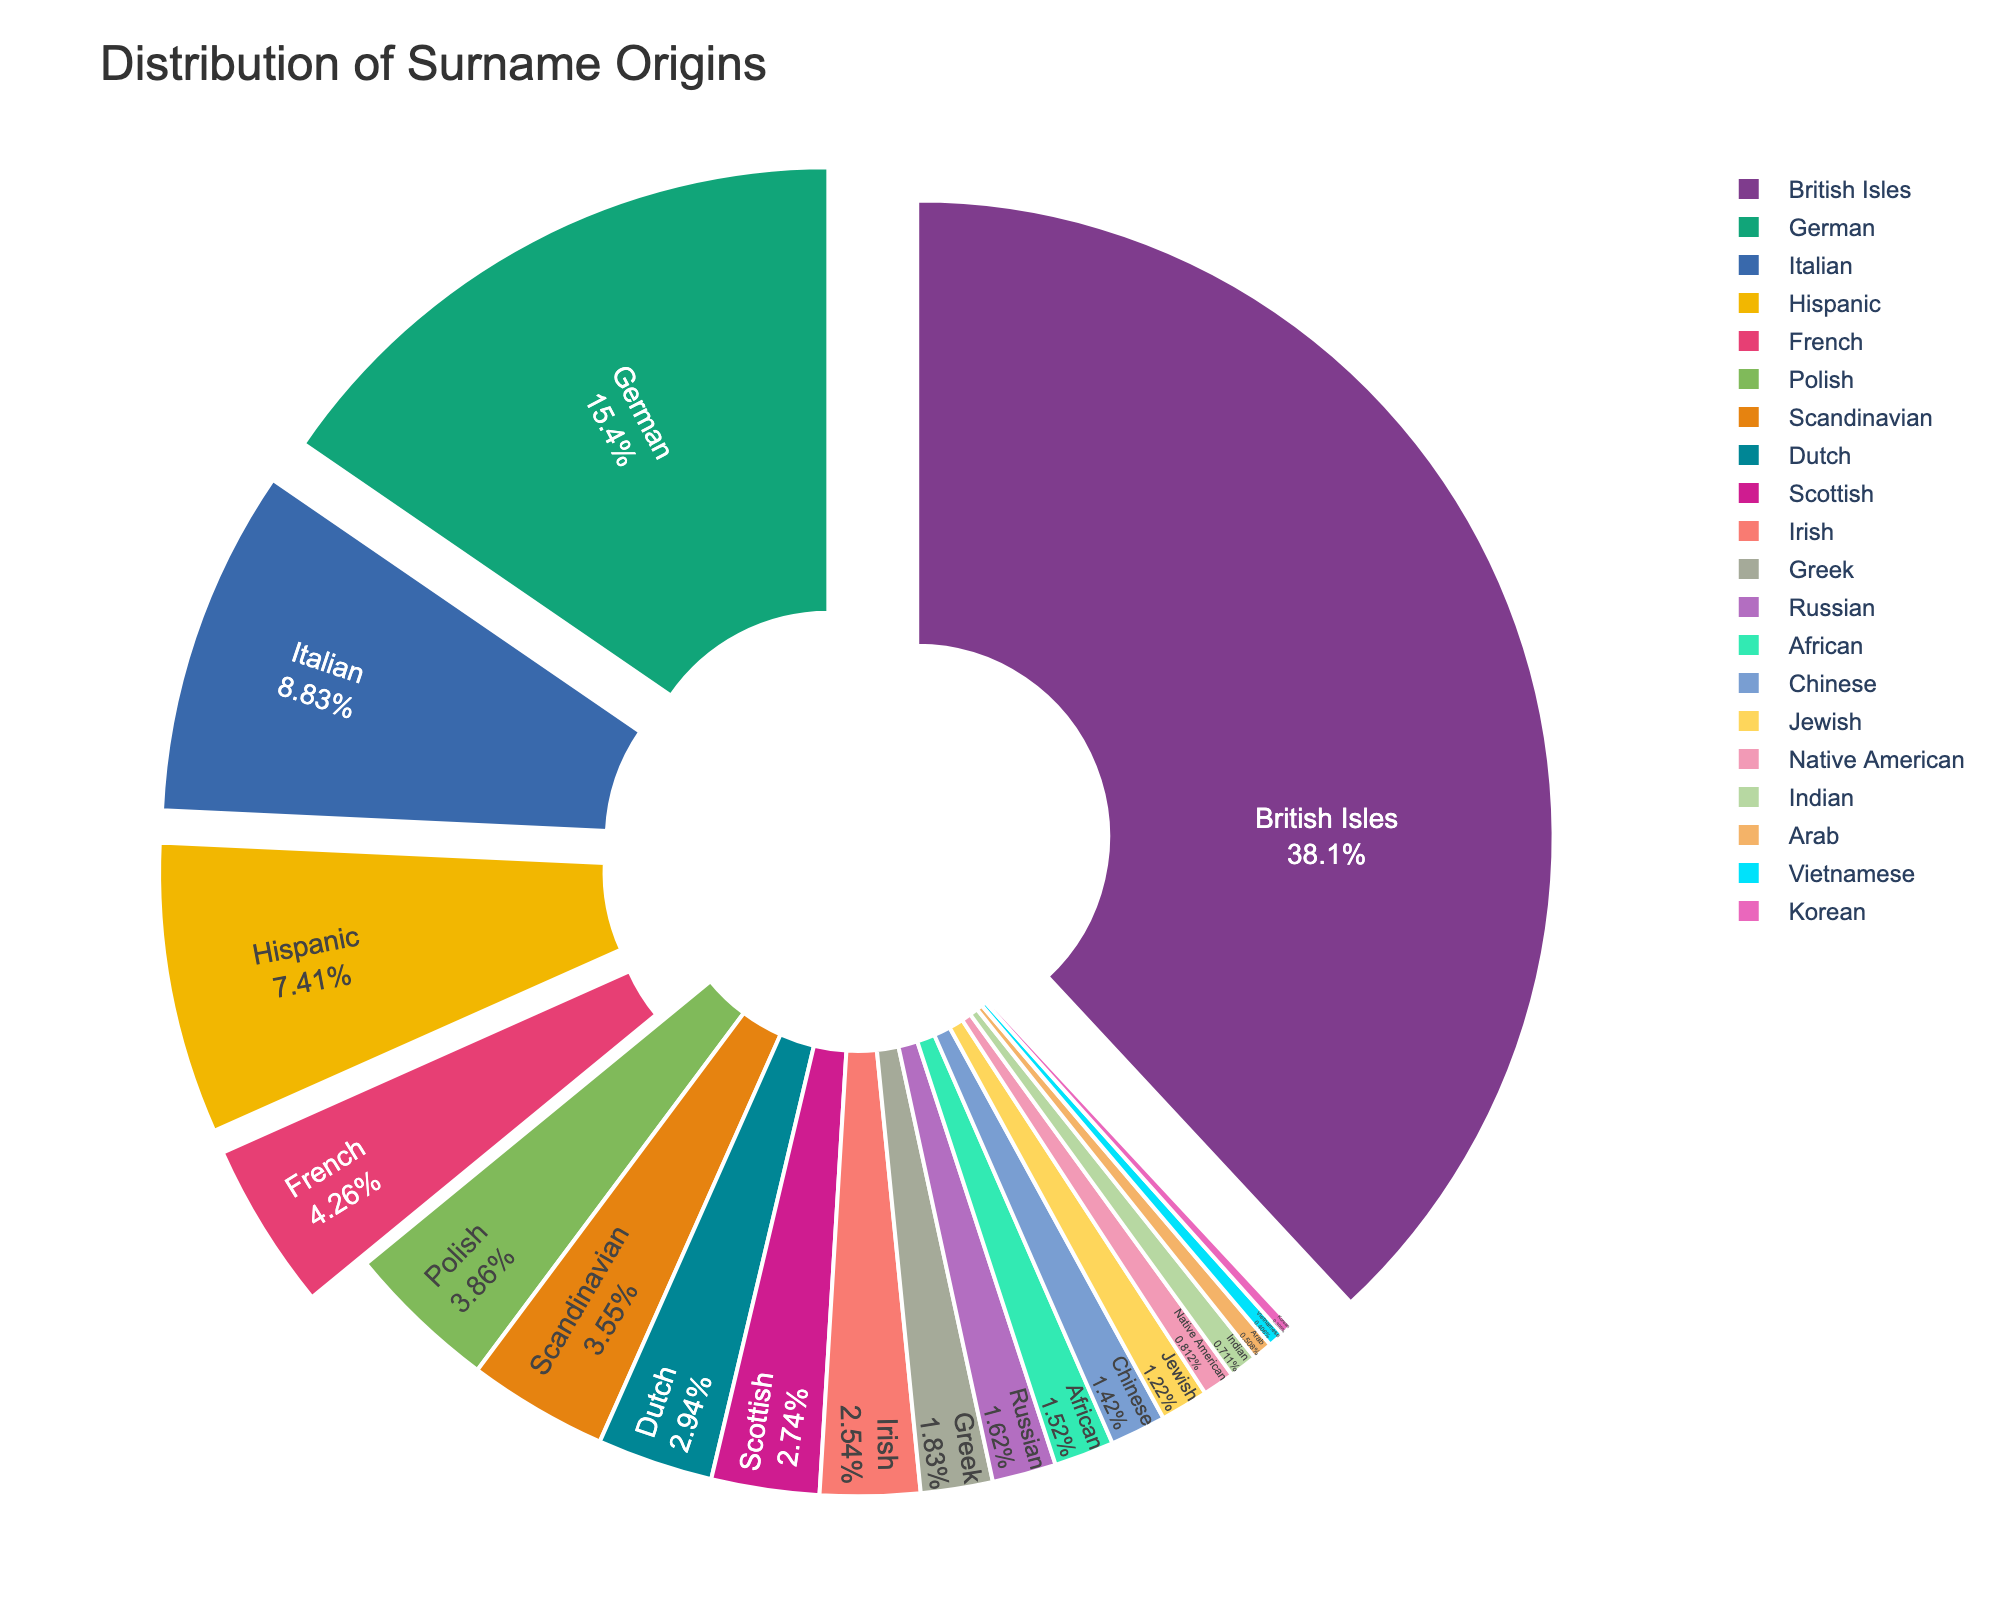What category has the largest percentage of surname origins? From the pie chart, the segment with the largest area represents the surname origins with the highest percentage. According to the chart, the British Isles has the largest area.
Answer: British Isles Which surname origin has a greater percentage: Italian or Hispanic? By comparing the two segments in the pie chart, we see that the Italian segment is slightly larger than the Hispanic segment.
Answer: Italian What is the combined percentage of surname origins from German and Italian? Add the percentages of both German (15.2%) and Italian (8.7%) origins: 15.2 + 8.7 = 23.9%
Answer: 23.9% Which surname origin has the smallest percentage? The smallest segment in the pie chart represents the surname origin with the smallest percentage. The Korean segment is the smallest.
Answer: Korean How does the percentage of Polish surname origins compare to that of Scandinavian surname origins? By comparing the two segments in the pie chart, the Polish segment (3.8%) is slightly larger than the Scandinavian segment (3.5%).
Answer: Polish What is the sum of the percentages of the African, Chinese, and Jewish surname origins? Add the percentages of African (1.5%), Chinese (1.4%), and Jewish (1.2%) origins: 1.5 + 1.4 + 1.2 = 4.1%
Answer: 4.1% Which surname origin category has a percentage close to 3%? By examining the pie chart, the Dutch (2.9%) and Polish (3.8%) segments are close to 3%.
Answer: Dutch Is the percentage of Native American surname origins greater or less than 1%? The pie chart shows the Native American segment as 0.8%, which is less than 1%.
Answer: Less than 1% What is the total percentage of the top three largest surname origin categories? Add the percentages of the British Isles (37.5%), German (15.2%), and Italian (8.7%) origins: 37.5 + 15.2 + 8.7 = 61.4%
Answer: 61.4% Which origin has a larger percentage, Greek or Russian? From the pie chart, the Greek segment (1.8%) is larger than the Russian segment (1.6%).
Answer: Greek 